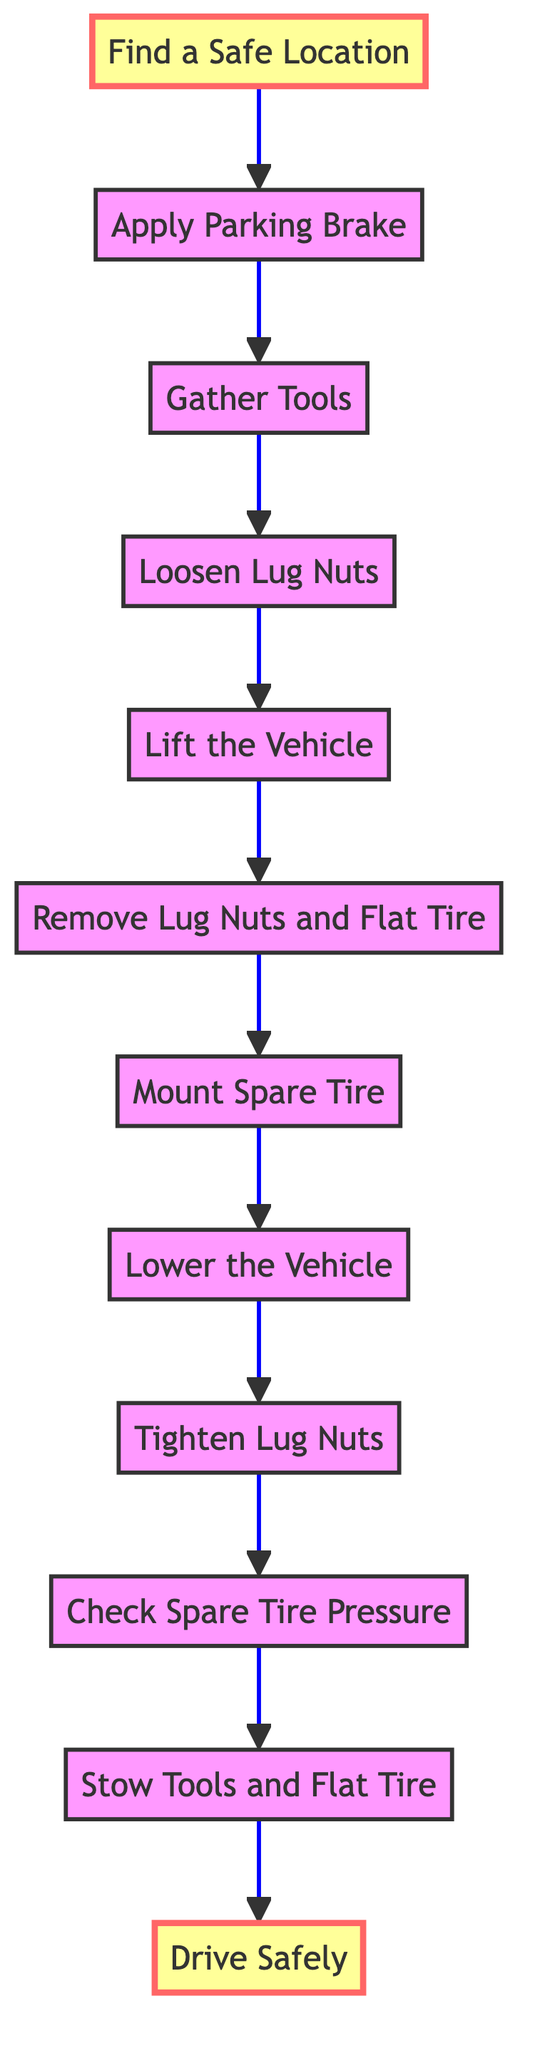What is the first step in changing a flat tire? The diagram shows that the first step is "Find a Safe Location", which is represented as the first node in the flow chart.
Answer: Find a Safe Location How many total steps are there in the instruction? By counting the individual steps listed in the flow chart, there are a total of 12 steps.
Answer: 12 What step comes immediately after "Lift the Vehicle"? In the flow chart, the step that comes immediately after "Lift the Vehicle" is "Remove Lug Nuts and Flat Tire", which follows directly from the previous step.
Answer: Remove Lug Nuts and Flat Tire What is the final step in the process? The flow chart identifies "Drive Safely" as the last step, indicating what you should do after completing the other steps.
Answer: Drive Safely Which step involves ensuring that the spare tire is inflated? The step that addresses this concern is "Check Spare Tire Pressure", where it is indicated that you should ensure the spare tire is properly inflated.
Answer: Check Spare Tire Pressure What are the first two steps in the process of changing a flat tire? The flow chart shows that the first two steps are "Find a Safe Location" followed by "Apply Parking Brake", indicating the sequence to start the procedure.
Answer: Find a Safe Location, Apply Parking Brake How is "Tighten Lug Nuts" related to "Mount Spare Tire"? The flow chart indicates that "Tighten Lug Nuts" follows after "Mount Spare Tire", showing a direct progression in the task of properly securing the spare tire.
Answer: Tighten Lug Nuts What should you do before driving away with the spare tire? According to the flow chart, you need to "Check Spare Tire Pressure" to ensure the spare tire is properly inflated before you drive.
Answer: Check Spare Tire Pressure What tool do you need to loosen the lug nuts? The diagram specifies that you need a "lug wrench" for the step "Loosen Lug Nuts", making it clear which tool is necessary for that action.
Answer: lug wrench 